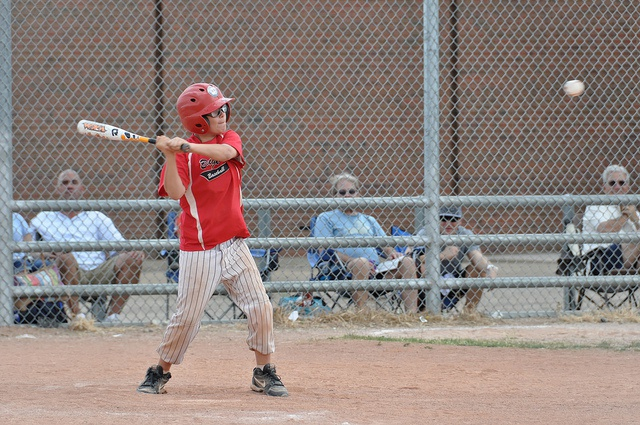Describe the objects in this image and their specific colors. I can see people in gray, darkgray, and brown tones, people in gray, darkgray, and lightblue tones, people in gray, darkgray, and lightblue tones, people in gray, darkgray, and black tones, and people in gray, darkgray, black, and lightgray tones in this image. 